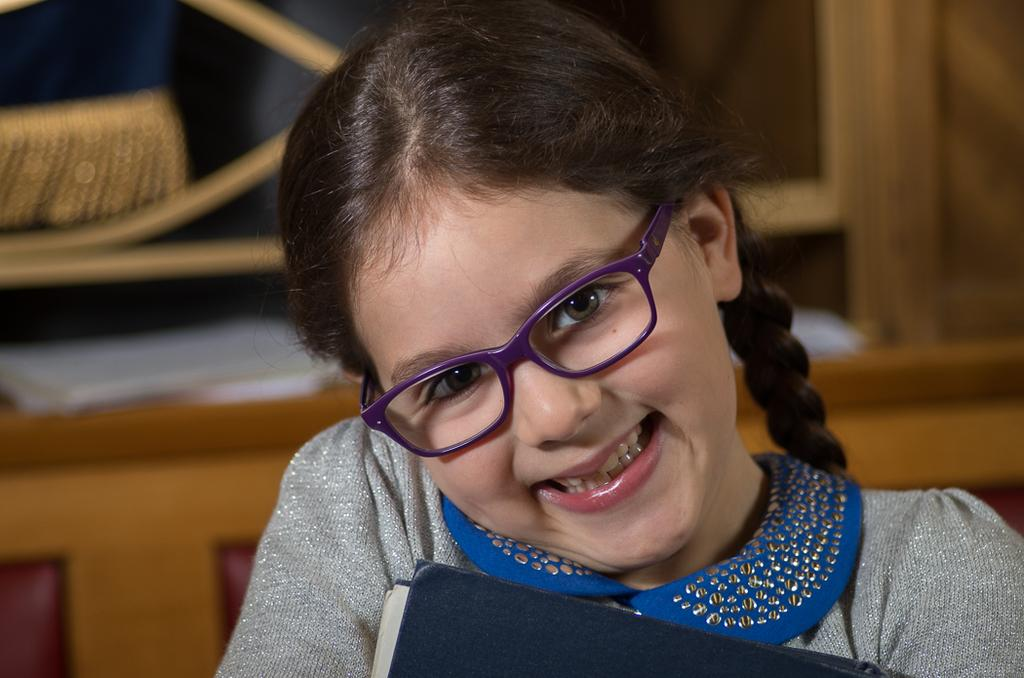Who is the main subject in the image? There is a girl in the image. What is the girl wearing? The girl is wearing a gray T-shirt. Are there any accessories visible on the girl? Yes, the girl is wearing spectacles. What is the girl's facial expression? The girl is smiling. What is the girl holding in the image? The girl is holding a book. Can you describe the background of the image? The background of the image is blurred. What type of chalk is the girl using to write on the store's window in the image? There is no store or chalk present in the image; the girl is holding a book and wearing spectacles. 